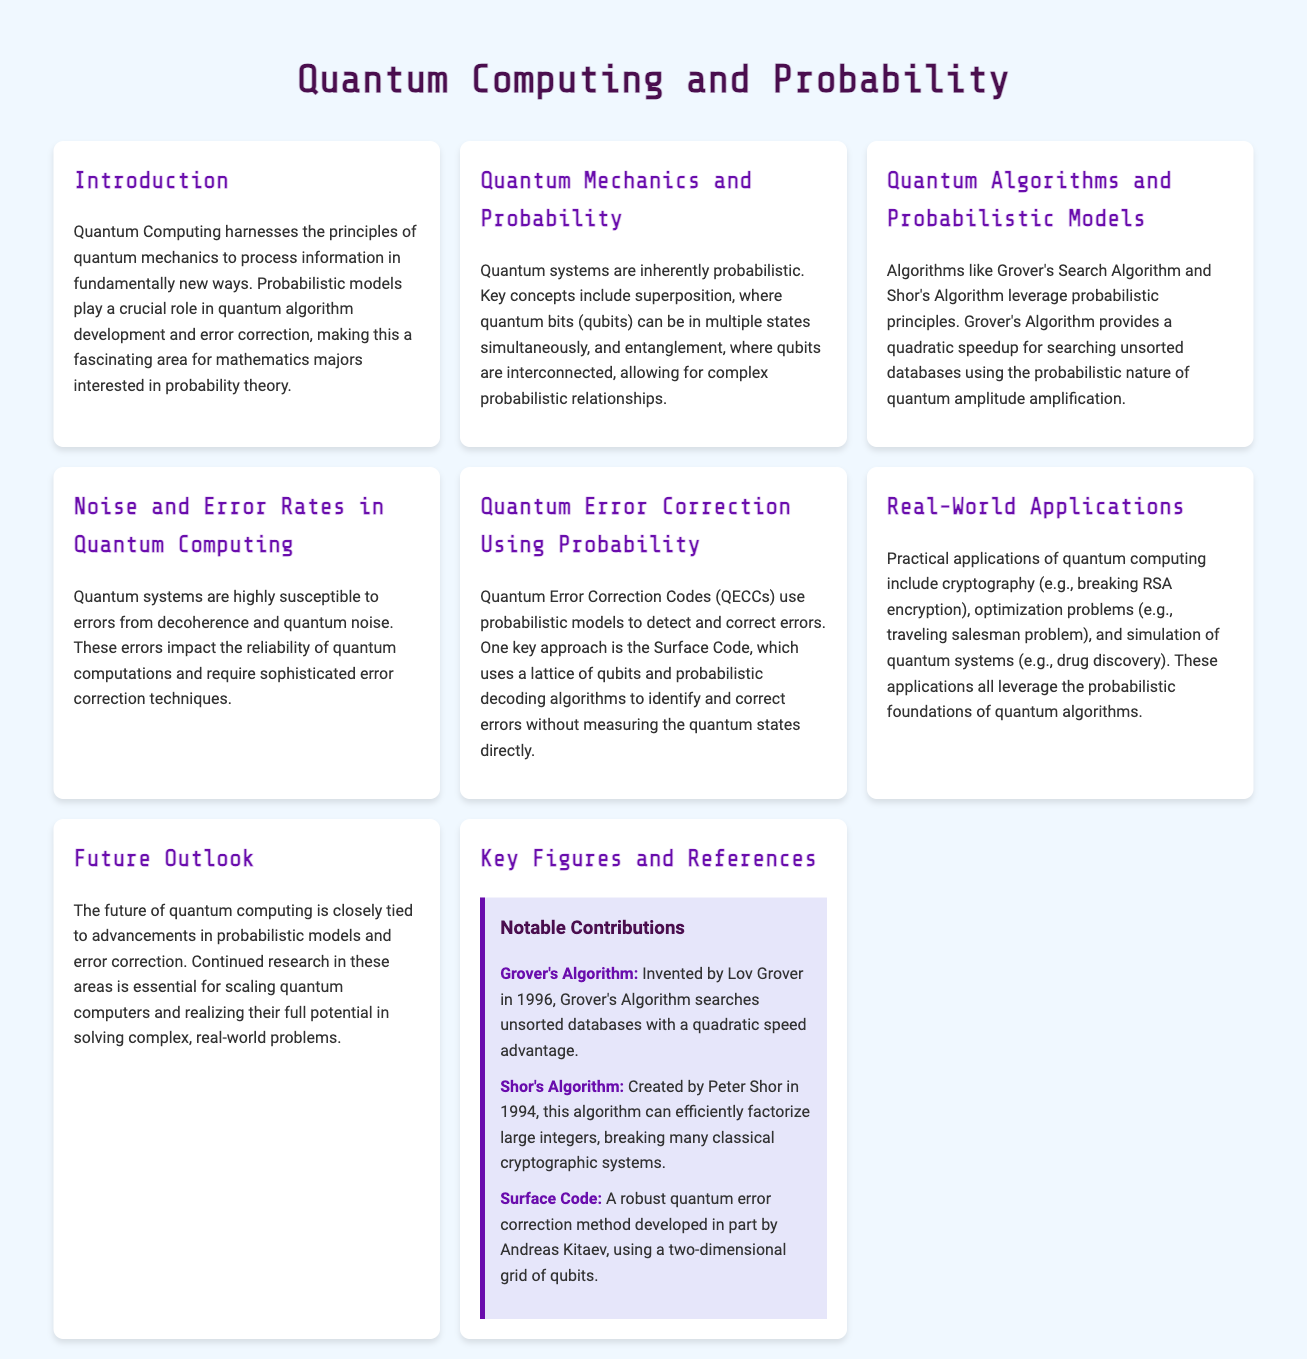What is the title of the document? The title of the document is displayed prominently at the top of the infographic.
Answer: Quantum Computing and Probability Who invented Grover's Algorithm? Grover's Algorithm is mentioned along with its inventor in the key figures section.
Answer: Lov Grover What year was Shor's Algorithm created? The year associated with Shor's Algorithm creation is mentioned in the key figures section.
Answer: 1994 What are qubits susceptible to? The document outlines what affects the reliability of quantum computations, specifically mentioned in the noise and error rates section.
Answer: Errors from decoherence and quantum noise What is one application of quantum computing mentioned? The real-world applications section lists various uses of quantum computing.
Answer: Cryptography What probabilistic model is used in Quantum Error Correction? The specific error correction method employing a probabilistic approach is detailed in the quantum error correction section.
Answer: Surface Code What significant advantage does Grover's Algorithm offer in searching? The speed advantage provided by Grover's Algorithm is highlighted in the algorithms section of the document.
Answer: Quadratic speedup What type of relationship do entangled qubits allow? The document describes a specific feature of entangled qubits related to probabilistic systems.
Answer: Complex probabilistic relationships 